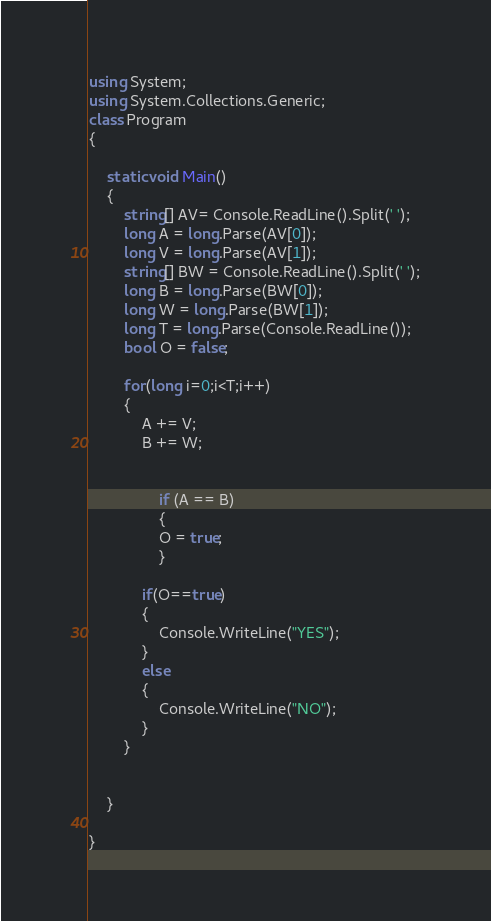Convert code to text. <code><loc_0><loc_0><loc_500><loc_500><_C#_>using System;
using System.Collections.Generic;
class Program
{

    static void Main()
    {
        string[] AV= Console.ReadLine().Split(' ');
        long A = long.Parse(AV[0]);
        long V = long.Parse(AV[1]);
        string[] BW = Console.ReadLine().Split(' ');
        long B = long.Parse(BW[0]);
        long W = long.Parse(BW[1]);
        long T = long.Parse(Console.ReadLine());
        bool O = false;

        for(long i=0;i<T;i++)
        {
            A += V;
            B += W;

            
                if (A == B)
                {
                O = true;
                }
               
            if(O==true)
            {
                Console.WriteLine("YES");
            }
            else
            {
                Console.WriteLine("NO");
            }
        }


    }

}</code> 